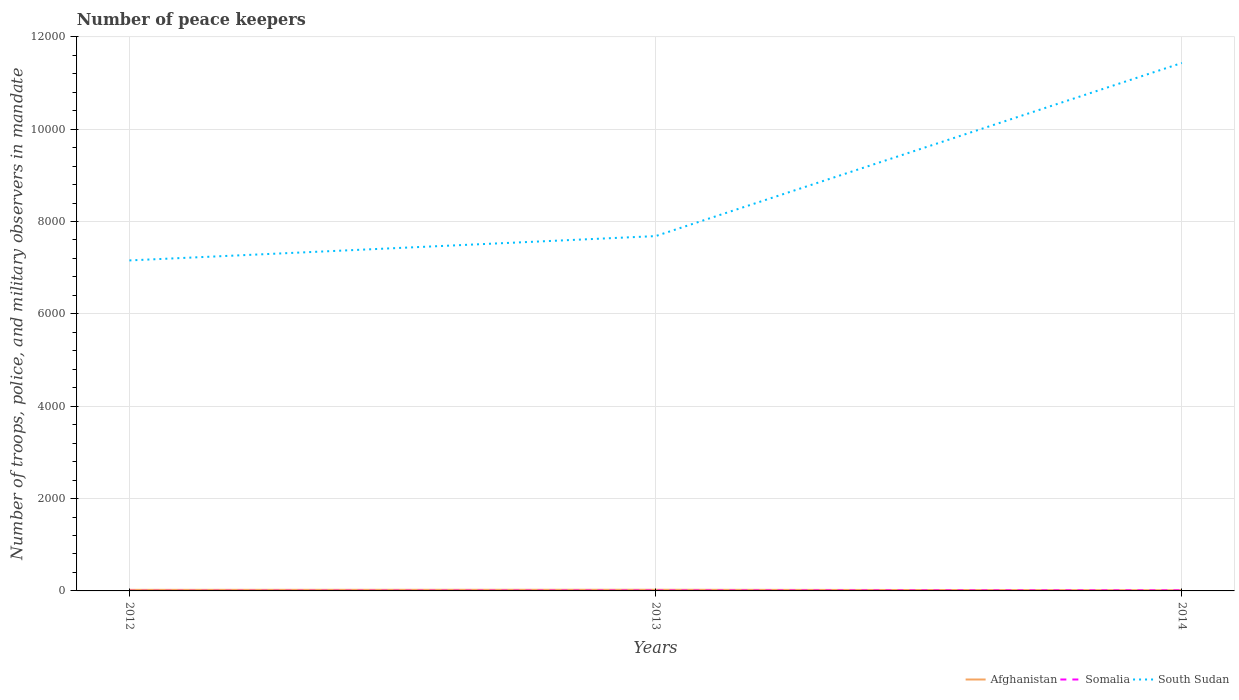How many different coloured lines are there?
Make the answer very short. 3. Does the line corresponding to South Sudan intersect with the line corresponding to Somalia?
Give a very brief answer. No. Is the number of lines equal to the number of legend labels?
Offer a terse response. Yes. In which year was the number of peace keepers in in Somalia maximum?
Your answer should be very brief. 2012. What is the total number of peace keepers in in Somalia in the graph?
Your answer should be compact. -6. What is the difference between the highest and the second highest number of peace keepers in in Somalia?
Offer a terse response. 9. What is the difference between the highest and the lowest number of peace keepers in in Somalia?
Offer a terse response. 2. Is the number of peace keepers in in South Sudan strictly greater than the number of peace keepers in in Somalia over the years?
Offer a terse response. No. How many years are there in the graph?
Provide a succinct answer. 3. Are the values on the major ticks of Y-axis written in scientific E-notation?
Your response must be concise. No. Does the graph contain any zero values?
Keep it short and to the point. No. Does the graph contain grids?
Your response must be concise. Yes. How many legend labels are there?
Offer a very short reply. 3. How are the legend labels stacked?
Make the answer very short. Horizontal. What is the title of the graph?
Offer a terse response. Number of peace keepers. Does "Sudan" appear as one of the legend labels in the graph?
Make the answer very short. No. What is the label or title of the Y-axis?
Give a very brief answer. Number of troops, police, and military observers in mandate. What is the Number of troops, police, and military observers in mandate of Somalia in 2012?
Your response must be concise. 3. What is the Number of troops, police, and military observers in mandate of South Sudan in 2012?
Provide a short and direct response. 7157. What is the Number of troops, police, and military observers in mandate of Afghanistan in 2013?
Offer a terse response. 25. What is the Number of troops, police, and military observers in mandate in Somalia in 2013?
Keep it short and to the point. 9. What is the Number of troops, police, and military observers in mandate in South Sudan in 2013?
Ensure brevity in your answer.  7684. What is the Number of troops, police, and military observers in mandate in South Sudan in 2014?
Your answer should be very brief. 1.14e+04. Across all years, what is the maximum Number of troops, police, and military observers in mandate in Afghanistan?
Make the answer very short. 25. Across all years, what is the maximum Number of troops, police, and military observers in mandate of Somalia?
Provide a short and direct response. 12. Across all years, what is the maximum Number of troops, police, and military observers in mandate of South Sudan?
Your response must be concise. 1.14e+04. Across all years, what is the minimum Number of troops, police, and military observers in mandate of Somalia?
Your response must be concise. 3. Across all years, what is the minimum Number of troops, police, and military observers in mandate in South Sudan?
Provide a succinct answer. 7157. What is the total Number of troops, police, and military observers in mandate in Afghanistan in the graph?
Offer a terse response. 63. What is the total Number of troops, police, and military observers in mandate in South Sudan in the graph?
Ensure brevity in your answer.  2.63e+04. What is the difference between the Number of troops, police, and military observers in mandate in Somalia in 2012 and that in 2013?
Offer a very short reply. -6. What is the difference between the Number of troops, police, and military observers in mandate in South Sudan in 2012 and that in 2013?
Offer a terse response. -527. What is the difference between the Number of troops, police, and military observers in mandate in Afghanistan in 2012 and that in 2014?
Give a very brief answer. 8. What is the difference between the Number of troops, police, and military observers in mandate in Somalia in 2012 and that in 2014?
Give a very brief answer. -9. What is the difference between the Number of troops, police, and military observers in mandate of South Sudan in 2012 and that in 2014?
Your answer should be compact. -4276. What is the difference between the Number of troops, police, and military observers in mandate of Afghanistan in 2013 and that in 2014?
Make the answer very short. 10. What is the difference between the Number of troops, police, and military observers in mandate in South Sudan in 2013 and that in 2014?
Give a very brief answer. -3749. What is the difference between the Number of troops, police, and military observers in mandate of Afghanistan in 2012 and the Number of troops, police, and military observers in mandate of South Sudan in 2013?
Give a very brief answer. -7661. What is the difference between the Number of troops, police, and military observers in mandate of Somalia in 2012 and the Number of troops, police, and military observers in mandate of South Sudan in 2013?
Your answer should be very brief. -7681. What is the difference between the Number of troops, police, and military observers in mandate in Afghanistan in 2012 and the Number of troops, police, and military observers in mandate in South Sudan in 2014?
Give a very brief answer. -1.14e+04. What is the difference between the Number of troops, police, and military observers in mandate in Somalia in 2012 and the Number of troops, police, and military observers in mandate in South Sudan in 2014?
Ensure brevity in your answer.  -1.14e+04. What is the difference between the Number of troops, police, and military observers in mandate in Afghanistan in 2013 and the Number of troops, police, and military observers in mandate in Somalia in 2014?
Offer a terse response. 13. What is the difference between the Number of troops, police, and military observers in mandate in Afghanistan in 2013 and the Number of troops, police, and military observers in mandate in South Sudan in 2014?
Give a very brief answer. -1.14e+04. What is the difference between the Number of troops, police, and military observers in mandate of Somalia in 2013 and the Number of troops, police, and military observers in mandate of South Sudan in 2014?
Offer a terse response. -1.14e+04. What is the average Number of troops, police, and military observers in mandate in South Sudan per year?
Your answer should be compact. 8758. In the year 2012, what is the difference between the Number of troops, police, and military observers in mandate of Afghanistan and Number of troops, police, and military observers in mandate of South Sudan?
Offer a very short reply. -7134. In the year 2012, what is the difference between the Number of troops, police, and military observers in mandate in Somalia and Number of troops, police, and military observers in mandate in South Sudan?
Your answer should be compact. -7154. In the year 2013, what is the difference between the Number of troops, police, and military observers in mandate of Afghanistan and Number of troops, police, and military observers in mandate of Somalia?
Your answer should be very brief. 16. In the year 2013, what is the difference between the Number of troops, police, and military observers in mandate of Afghanistan and Number of troops, police, and military observers in mandate of South Sudan?
Make the answer very short. -7659. In the year 2013, what is the difference between the Number of troops, police, and military observers in mandate of Somalia and Number of troops, police, and military observers in mandate of South Sudan?
Your answer should be very brief. -7675. In the year 2014, what is the difference between the Number of troops, police, and military observers in mandate in Afghanistan and Number of troops, police, and military observers in mandate in Somalia?
Offer a terse response. 3. In the year 2014, what is the difference between the Number of troops, police, and military observers in mandate of Afghanistan and Number of troops, police, and military observers in mandate of South Sudan?
Provide a short and direct response. -1.14e+04. In the year 2014, what is the difference between the Number of troops, police, and military observers in mandate in Somalia and Number of troops, police, and military observers in mandate in South Sudan?
Provide a short and direct response. -1.14e+04. What is the ratio of the Number of troops, police, and military observers in mandate in Afghanistan in 2012 to that in 2013?
Keep it short and to the point. 0.92. What is the ratio of the Number of troops, police, and military observers in mandate of Somalia in 2012 to that in 2013?
Provide a short and direct response. 0.33. What is the ratio of the Number of troops, police, and military observers in mandate of South Sudan in 2012 to that in 2013?
Offer a very short reply. 0.93. What is the ratio of the Number of troops, police, and military observers in mandate of Afghanistan in 2012 to that in 2014?
Offer a very short reply. 1.53. What is the ratio of the Number of troops, police, and military observers in mandate in Somalia in 2012 to that in 2014?
Your response must be concise. 0.25. What is the ratio of the Number of troops, police, and military observers in mandate in South Sudan in 2012 to that in 2014?
Offer a terse response. 0.63. What is the ratio of the Number of troops, police, and military observers in mandate in Afghanistan in 2013 to that in 2014?
Your answer should be compact. 1.67. What is the ratio of the Number of troops, police, and military observers in mandate of South Sudan in 2013 to that in 2014?
Your answer should be very brief. 0.67. What is the difference between the highest and the second highest Number of troops, police, and military observers in mandate of Afghanistan?
Your answer should be very brief. 2. What is the difference between the highest and the second highest Number of troops, police, and military observers in mandate of Somalia?
Give a very brief answer. 3. What is the difference between the highest and the second highest Number of troops, police, and military observers in mandate of South Sudan?
Ensure brevity in your answer.  3749. What is the difference between the highest and the lowest Number of troops, police, and military observers in mandate of Afghanistan?
Your answer should be very brief. 10. What is the difference between the highest and the lowest Number of troops, police, and military observers in mandate of Somalia?
Your answer should be compact. 9. What is the difference between the highest and the lowest Number of troops, police, and military observers in mandate in South Sudan?
Offer a very short reply. 4276. 